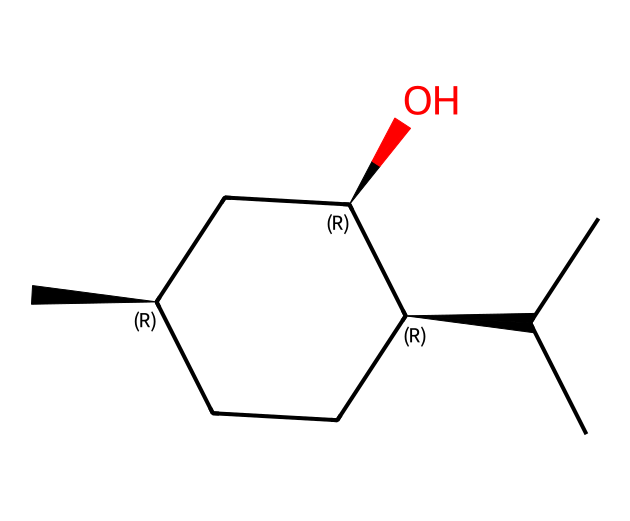What is the molecular formula of menthol? To find the molecular formula, count the number of carbon (C), hydrogen (H), and oxygen (O) atoms in the structure. There are 10 carbon atoms, 20 hydrogen atoms, and 1 oxygen atom in the SMILES representation. Thus, the molecular formula is C10H20O.
Answer: C10H20O How many chiral centers are present in menthol? Chiral centers are typically indicated by stereochemistry in the SMILES. In this structure, there are three chiral centers marked by the stereochemistry symbols, indicating that they can exist in two enantiomeric forms.
Answer: 3 What type of compound is menthol classified as? Menthol is derived from mint and has a specific structure that characterizes it as a cyclic monoterpene alcohol. This classification is indicated by the presence of the hydroxyl (–OH) group and the cyclic structure.
Answer: cyclic monoterpene alcohol Which functional group is present in menthol? Identifying functional groups involves looking for specific atoms or groups of atoms characteristic of specific behaviors. In this SMILES representation, the –OH indicates an alcohol functional group.
Answer: alcohol How does menthol contribute to the cooling sensation? The specific arrangement of atoms and the presence of the hydroxyl group allow menthol to interact with the thermoreceptors in the skin, mimicking cold temperatures.
Answer: cooling sensation What is the total number of bonds in menthol? To find the total number of bonds, account for each single, double, and triple bond in the structure. By systematically reviewing the molecule, you determine the number of each type of bond and sum them. In menthol, there are 13 bonds in total.
Answer: 13 